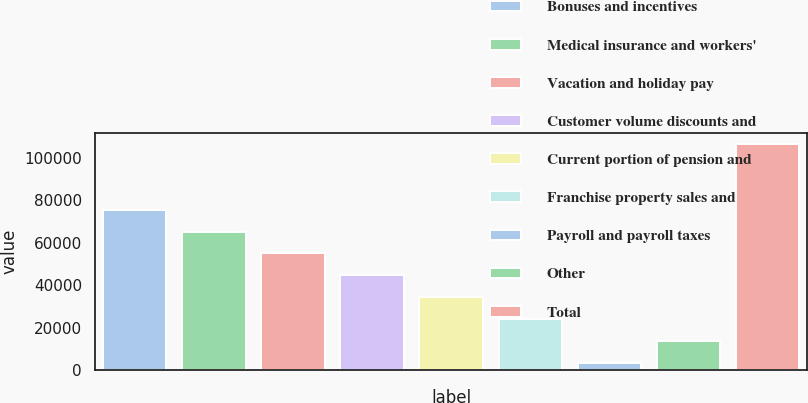Convert chart to OTSL. <chart><loc_0><loc_0><loc_500><loc_500><bar_chart><fcel>Bonuses and incentives<fcel>Medical insurance and workers'<fcel>Vacation and holiday pay<fcel>Customer volume discounts and<fcel>Current portion of pension and<fcel>Franchise property sales and<fcel>Payroll and payroll taxes<fcel>Other<fcel>Total<nl><fcel>75604.3<fcel>65276.4<fcel>54948.5<fcel>44620.6<fcel>34292.7<fcel>23964.8<fcel>3309<fcel>13636.9<fcel>106588<nl></chart> 